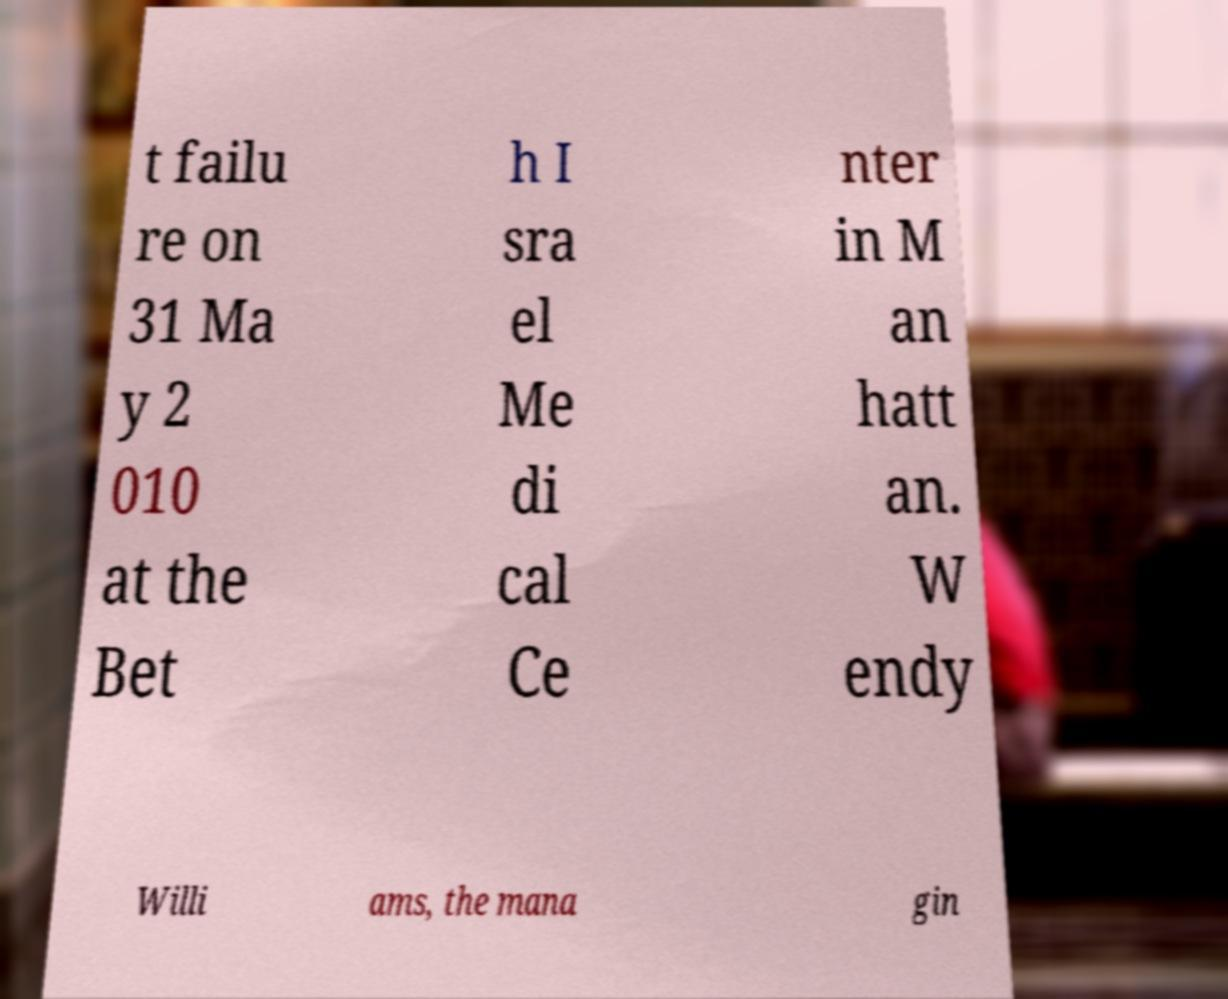Could you extract and type out the text from this image? t failu re on 31 Ma y 2 010 at the Bet h I sra el Me di cal Ce nter in M an hatt an. W endy Willi ams, the mana gin 